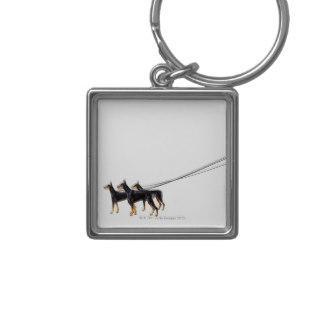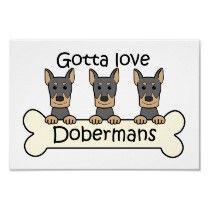The first image is the image on the left, the second image is the image on the right. Considering the images on both sides, is "there is a keychain with3 dogs on it" valid? Answer yes or no. Yes. The first image is the image on the left, the second image is the image on the right. Analyze the images presented: Is the assertion "One image shows a silver keychain featuring a dog theme, and the other image contains a white rectangle with a dog theme." valid? Answer yes or no. Yes. 